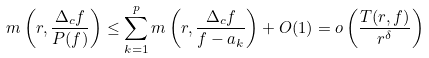Convert formula to latex. <formula><loc_0><loc_0><loc_500><loc_500>m \left ( r , \frac { \Delta _ { c } f } { P ( f ) } \right ) \leq \sum _ { k = 1 } ^ { p } m \left ( r , \frac { \Delta _ { c } f } { f - a _ { k } } \right ) + O ( 1 ) = o \left ( \frac { T ( r , f ) } { r ^ { \delta } } \right )</formula> 